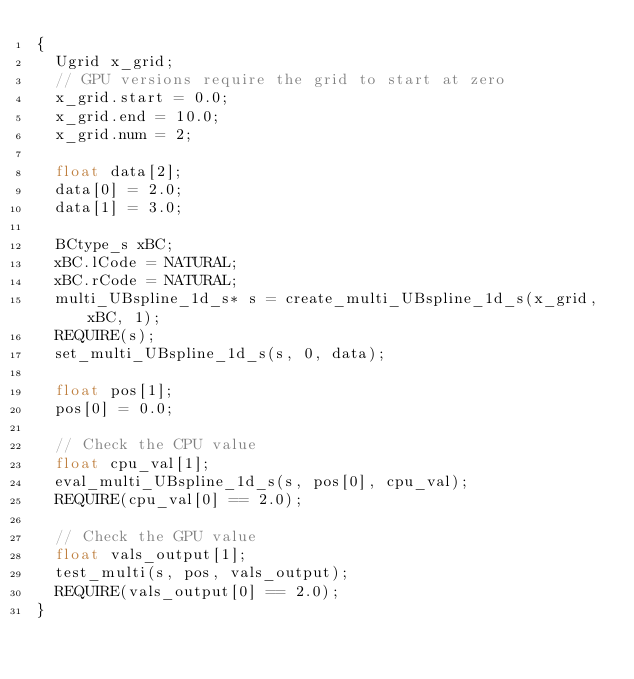<code> <loc_0><loc_0><loc_500><loc_500><_Cuda_>{
  Ugrid x_grid;
  // GPU versions require the grid to start at zero
  x_grid.start = 0.0;
  x_grid.end = 10.0;
  x_grid.num = 2;

  float data[2];
  data[0] = 2.0;
  data[1] = 3.0;

  BCtype_s xBC;
  xBC.lCode = NATURAL;
  xBC.rCode = NATURAL;
  multi_UBspline_1d_s* s = create_multi_UBspline_1d_s(x_grid, xBC, 1);
  REQUIRE(s);
  set_multi_UBspline_1d_s(s, 0, data);

  float pos[1];
  pos[0] = 0.0;

  // Check the CPU value
  float cpu_val[1];
  eval_multi_UBspline_1d_s(s, pos[0], cpu_val);
  REQUIRE(cpu_val[0] == 2.0);

  // Check the GPU value
  float vals_output[1];
  test_multi(s, pos, vals_output);
  REQUIRE(vals_output[0] == 2.0);
}
</code> 